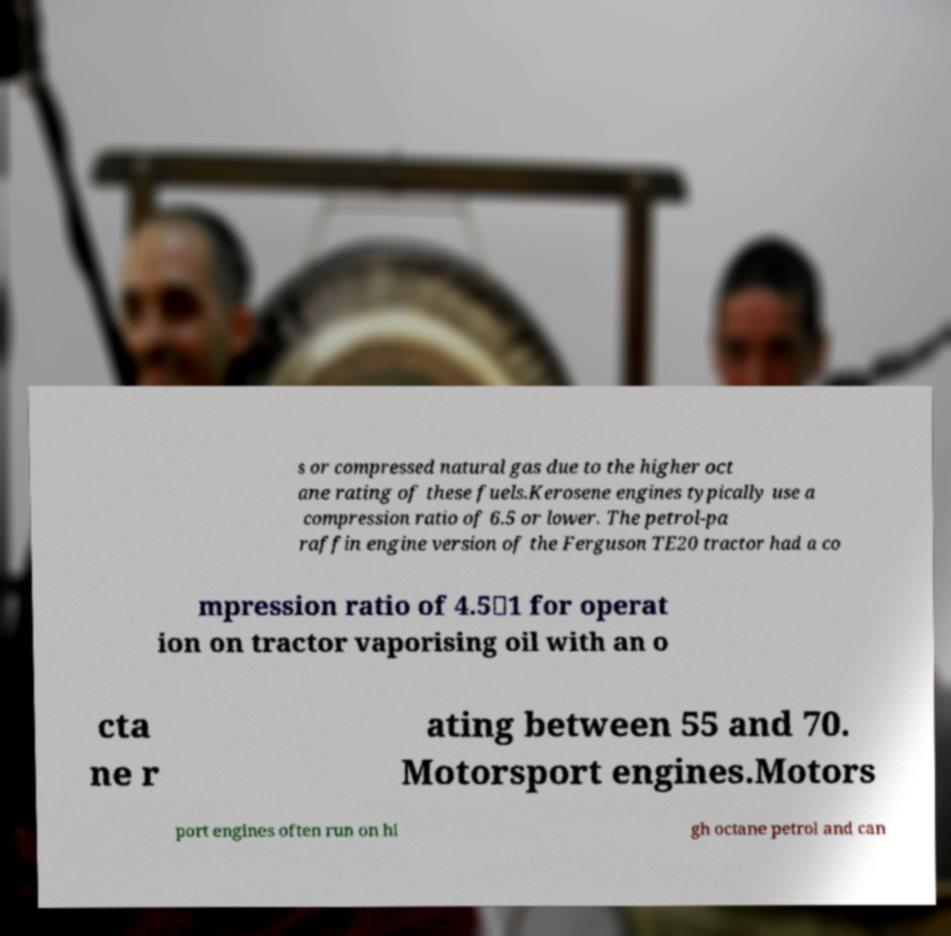Could you assist in decoding the text presented in this image and type it out clearly? s or compressed natural gas due to the higher oct ane rating of these fuels.Kerosene engines typically use a compression ratio of 6.5 or lower. The petrol-pa raffin engine version of the Ferguson TE20 tractor had a co mpression ratio of 4.5∶1 for operat ion on tractor vaporising oil with an o cta ne r ating between 55 and 70. Motorsport engines.Motors port engines often run on hi gh octane petrol and can 